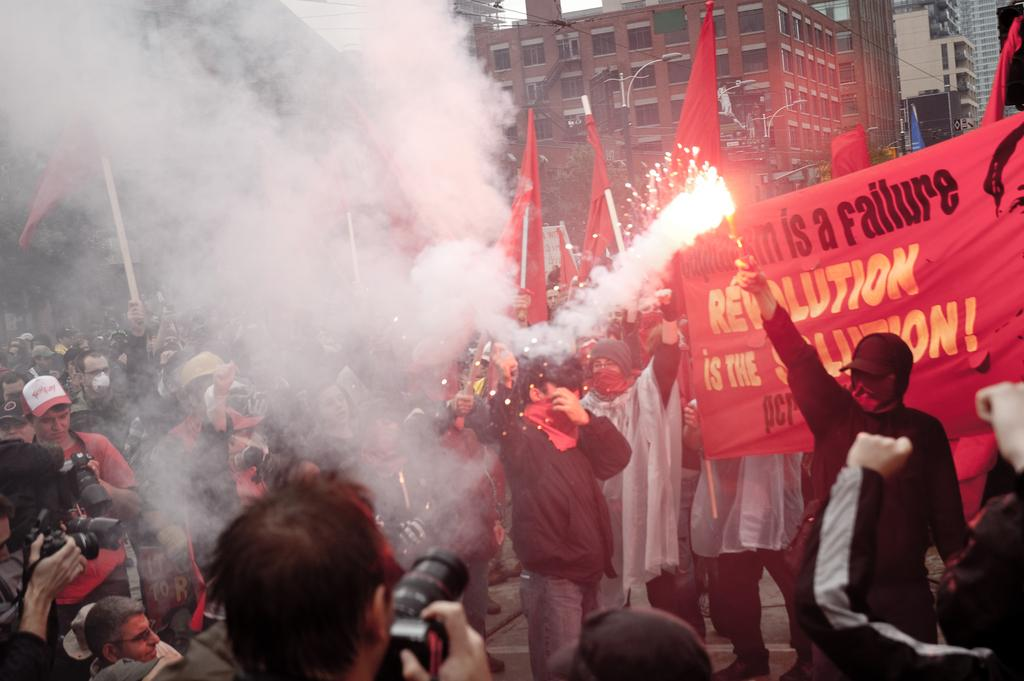<image>
Create a compact narrative representing the image presented. Protesters light fireworks in support of the Revolution is the Solution movement. 